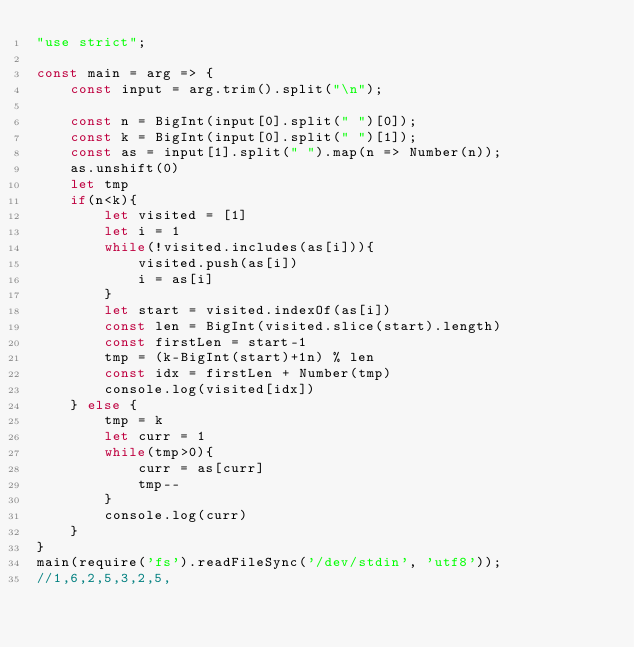<code> <loc_0><loc_0><loc_500><loc_500><_JavaScript_>"use strict";

const main = arg => {
    const input = arg.trim().split("\n");

    const n = BigInt(input[0].split(" ")[0]);
    const k = BigInt(input[0].split(" ")[1]);
    const as = input[1].split(" ").map(n => Number(n));
    as.unshift(0)
    let tmp
    if(n<k){
        let visited = [1]
        let i = 1
        while(!visited.includes(as[i])){
            visited.push(as[i])
            i = as[i]
        }
        let start = visited.indexOf(as[i])
        const len = BigInt(visited.slice(start).length)
        const firstLen = start-1
        tmp = (k-BigInt(start)+1n) % len
        const idx = firstLen + Number(tmp)
        console.log(visited[idx])
    } else {
        tmp = k
        let curr = 1
        while(tmp>0){
            curr = as[curr]
            tmp--
        }
        console.log(curr)
    }
}
main(require('fs').readFileSync('/dev/stdin', 'utf8'));  
//1,6,2,5,3,2,5,</code> 